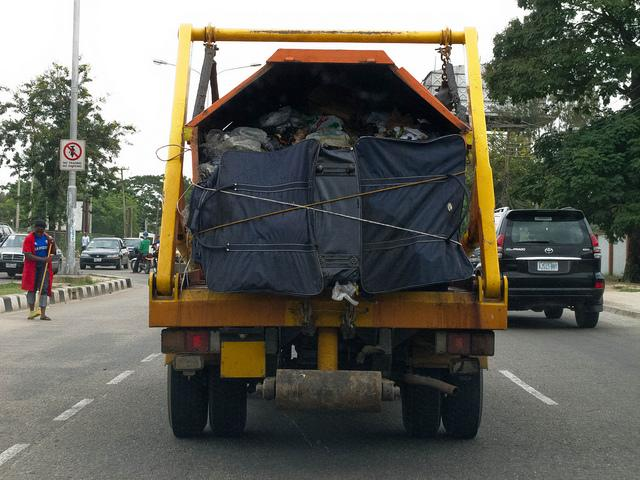Where might the truck in yellow be headed? Please explain your reasoning. junk yard. A truck is on the road and is full of garbage. 